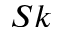<formula> <loc_0><loc_0><loc_500><loc_500>S k</formula> 